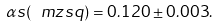<formula> <loc_0><loc_0><loc_500><loc_500>\alpha s ( \ m z s q ) = 0 . 1 2 0 \pm 0 . 0 0 3 .</formula> 